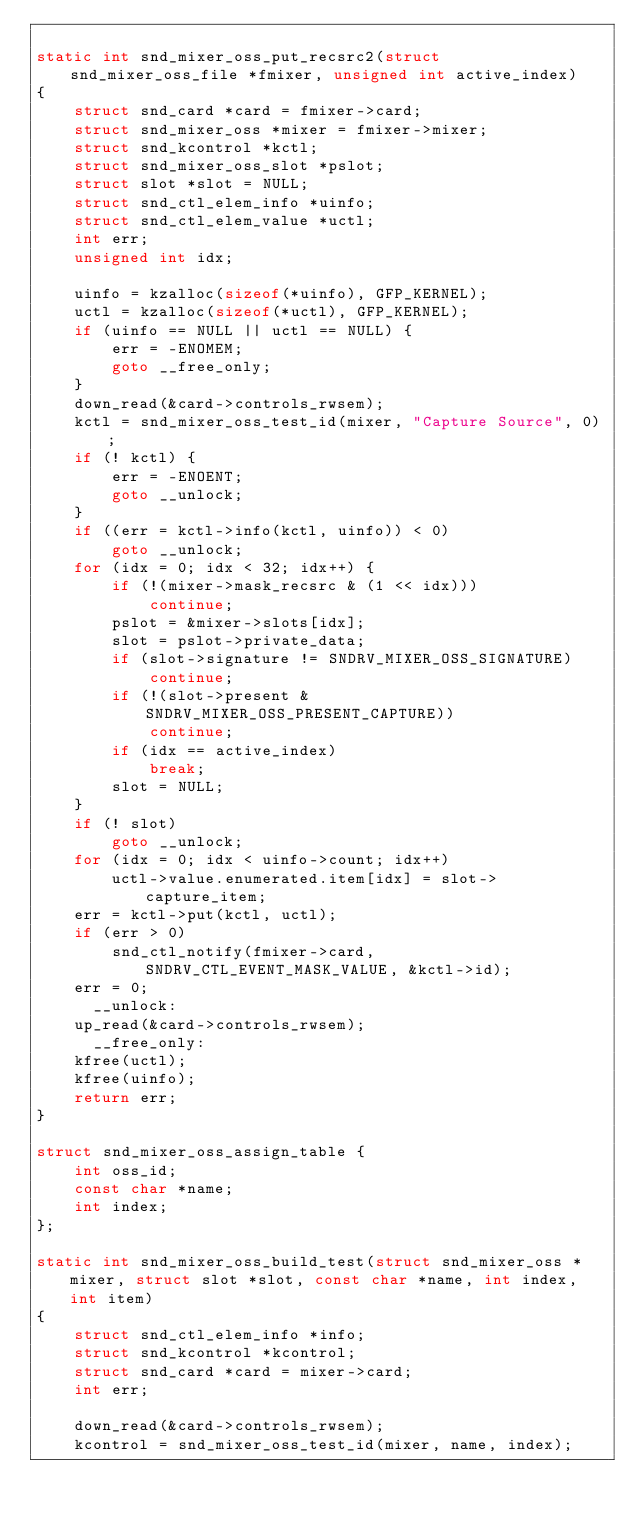Convert code to text. <code><loc_0><loc_0><loc_500><loc_500><_C_>
static int snd_mixer_oss_put_recsrc2(struct snd_mixer_oss_file *fmixer, unsigned int active_index)
{
	struct snd_card *card = fmixer->card;
	struct snd_mixer_oss *mixer = fmixer->mixer;
	struct snd_kcontrol *kctl;
	struct snd_mixer_oss_slot *pslot;
	struct slot *slot = NULL;
	struct snd_ctl_elem_info *uinfo;
	struct snd_ctl_elem_value *uctl;
	int err;
	unsigned int idx;

	uinfo = kzalloc(sizeof(*uinfo), GFP_KERNEL);
	uctl = kzalloc(sizeof(*uctl), GFP_KERNEL);
	if (uinfo == NULL || uctl == NULL) {
		err = -ENOMEM;
		goto __free_only;
	}
	down_read(&card->controls_rwsem);
	kctl = snd_mixer_oss_test_id(mixer, "Capture Source", 0);
	if (! kctl) {
		err = -ENOENT;
		goto __unlock;
	}
	if ((err = kctl->info(kctl, uinfo)) < 0)
		goto __unlock;
	for (idx = 0; idx < 32; idx++) {
		if (!(mixer->mask_recsrc & (1 << idx)))
			continue;
		pslot = &mixer->slots[idx];
		slot = pslot->private_data;
		if (slot->signature != SNDRV_MIXER_OSS_SIGNATURE)
			continue;
		if (!(slot->present & SNDRV_MIXER_OSS_PRESENT_CAPTURE))
			continue;
		if (idx == active_index)
			break;
		slot = NULL;
	}
	if (! slot)
		goto __unlock;
	for (idx = 0; idx < uinfo->count; idx++)
		uctl->value.enumerated.item[idx] = slot->capture_item;
	err = kctl->put(kctl, uctl);
	if (err > 0)
		snd_ctl_notify(fmixer->card, SNDRV_CTL_EVENT_MASK_VALUE, &kctl->id);
	err = 0;
      __unlock:
	up_read(&card->controls_rwsem);
      __free_only:
	kfree(uctl);
	kfree(uinfo);
	return err;
}

struct snd_mixer_oss_assign_table {
	int oss_id;
	const char *name;
	int index;
};

static int snd_mixer_oss_build_test(struct snd_mixer_oss *mixer, struct slot *slot, const char *name, int index, int item)
{
	struct snd_ctl_elem_info *info;
	struct snd_kcontrol *kcontrol;
	struct snd_card *card = mixer->card;
	int err;

	down_read(&card->controls_rwsem);
	kcontrol = snd_mixer_oss_test_id(mixer, name, index);</code> 